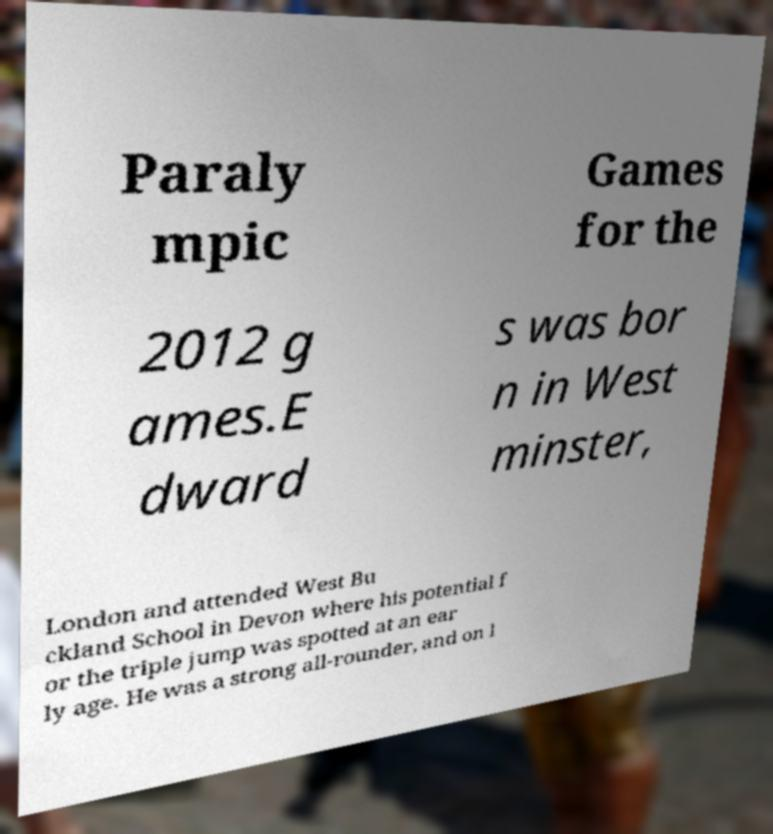Can you read and provide the text displayed in the image?This photo seems to have some interesting text. Can you extract and type it out for me? Paraly mpic Games for the 2012 g ames.E dward s was bor n in West minster, London and attended West Bu ckland School in Devon where his potential f or the triple jump was spotted at an ear ly age. He was a strong all-rounder, and on l 